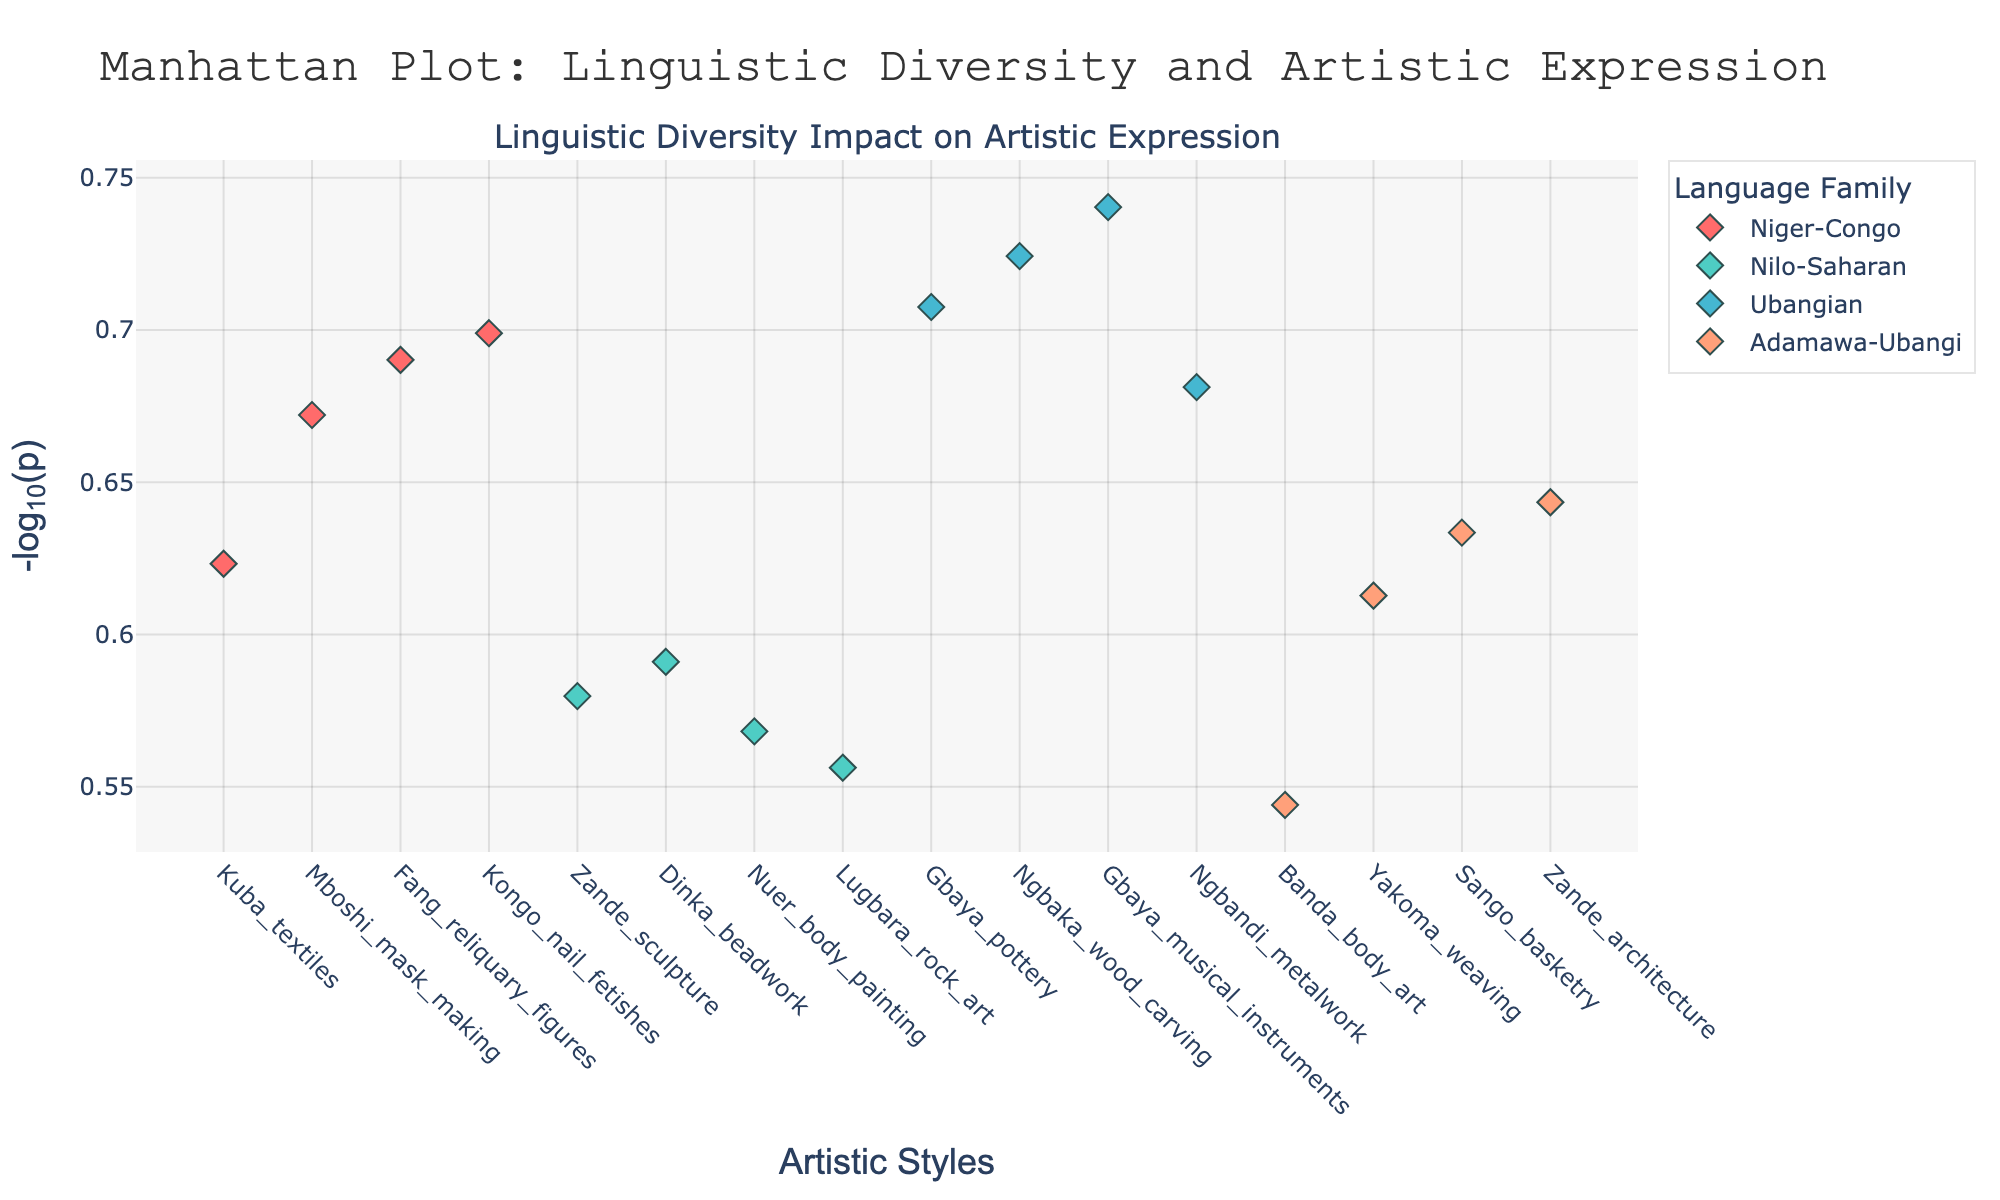Which artistic style has the highest significance score? Find the data point with the highest value on the y-axis (highest -log10(p)). The highest -log10(p) corresponds to Gbaya musical instruments from the Ubangian language family.
Answer: Gbaya musical instruments How many data points are there in the Niger-Congo language family? Count the number of markers belonging to the Niger-Congo language family in the figure. There are four markers.
Answer: Four What is the average -log10(p) value of the Adamawa-Ubangi language family? Sum the -log10(p) values for all data points in the Adamawa-Ubangi family, and divide by the number of points. The values are 0.47, 0.39, 0.36, 0.34. Sum = 1.56, Average = 1.56/4 = 0.39.
Answer: 0.39 Which language family has the most artistic styles represented? Identify the language family with the greatest number of distinct markers. The Niger-Congo family has the most markers.
Answer: Niger-Congo What is the color representing the Ubangian language family in the plot? Refer to the color of the markers associated with the Ubangian family. The color is #45B7D1.
Answer: #45B7D1 Which language family has the lowest -log10(p) value, and what is that value? Find the data point with the smallest y-axis value and its corresponding language family. The lowest -log10(p) is from the Adamawa-Ubangi family with Banda body art. The value is 0.34.
Answer: Adamawa-Ubangi, 0.34 How does the -log10(p) value of Kongo nail fetishes compare to that of Fang reliquary figures? Compare the y-axis values of these two Niger-Congo artistic styles. The -log10(p) for Kongo nail fetishes is 0.30, and for Fang reliquary figures, it is 0.31. Fang is slightly higher.
Answer: Fang reliquary figures have a higher -log10(p) What is the significance score for Zande sculpture from the Nilo-Saharan language family? Convert the -log10(p) value to the original significance score by calculating 10^(-y-value). The -log10(p) for Zande sculpture is 3.8, so the significance score is 10^(-3.8) = 0.0001585.
Answer: 0.0001585 